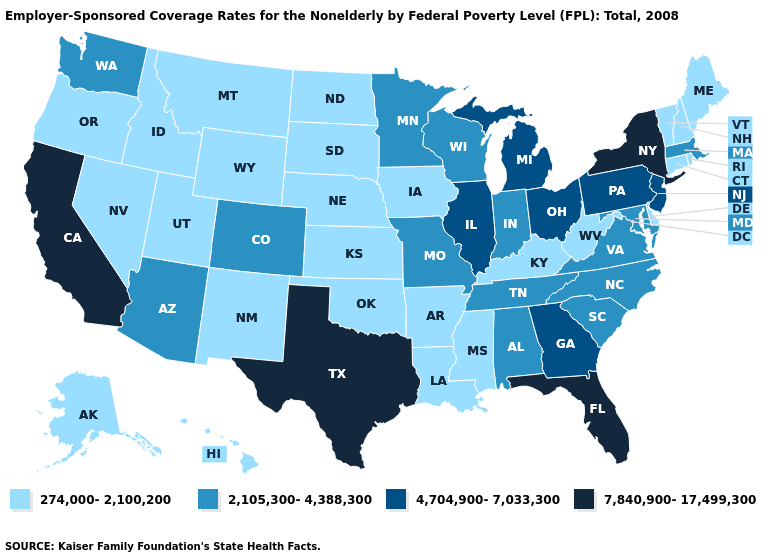Does Mississippi have a lower value than Maryland?
Write a very short answer. Yes. What is the value of Missouri?
Quick response, please. 2,105,300-4,388,300. Does Arizona have a lower value than Oklahoma?
Write a very short answer. No. Is the legend a continuous bar?
Give a very brief answer. No. Does Pennsylvania have the highest value in the Northeast?
Write a very short answer. No. What is the highest value in the USA?
Concise answer only. 7,840,900-17,499,300. Is the legend a continuous bar?
Concise answer only. No. Which states have the highest value in the USA?
Answer briefly. California, Florida, New York, Texas. What is the lowest value in the USA?
Give a very brief answer. 274,000-2,100,200. Does North Dakota have the lowest value in the MidWest?
Short answer required. Yes. Does North Carolina have the lowest value in the South?
Give a very brief answer. No. What is the value of Delaware?
Short answer required. 274,000-2,100,200. Name the states that have a value in the range 2,105,300-4,388,300?
Keep it brief. Alabama, Arizona, Colorado, Indiana, Maryland, Massachusetts, Minnesota, Missouri, North Carolina, South Carolina, Tennessee, Virginia, Washington, Wisconsin. Does Arizona have a higher value than Georgia?
Keep it brief. No. Among the states that border Oregon , does California have the lowest value?
Concise answer only. No. 